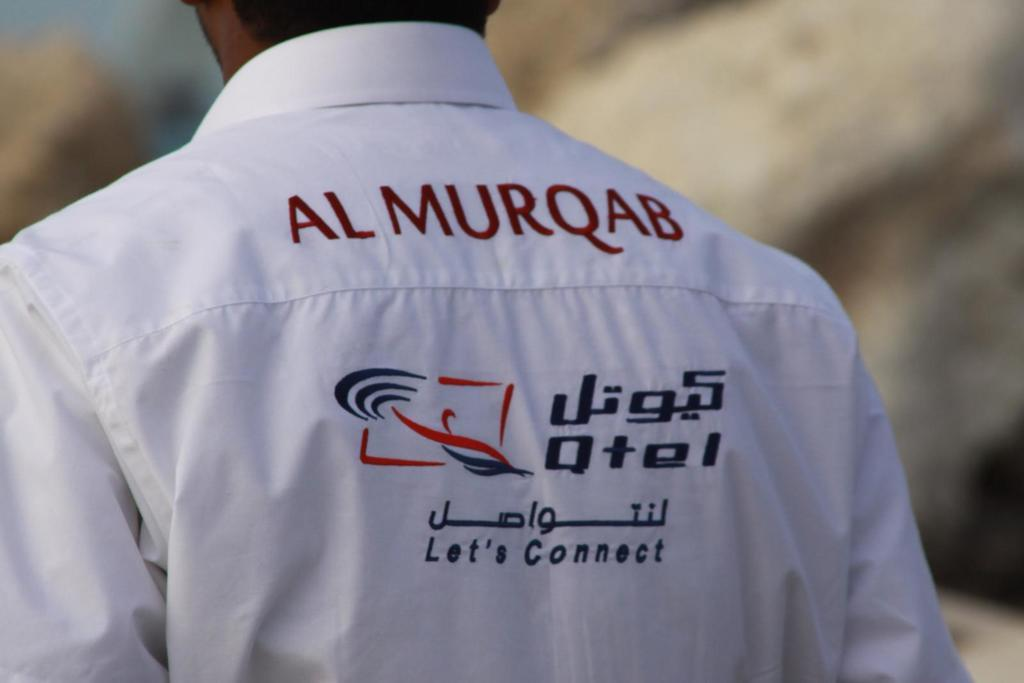<image>
Share a concise interpretation of the image provided. A man wears a shirt with Al Murqab on the back. 